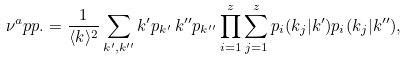Convert formula to latex. <formula><loc_0><loc_0><loc_500><loc_500>\nu ^ { a } p p . = \frac { 1 } { \langle k \rangle ^ { 2 } } \sum _ { k ^ { \prime } , k ^ { \prime \prime } } k ^ { \prime } p _ { k ^ { \prime } } \, k ^ { \prime \prime } p _ { k ^ { \prime \prime } } \prod _ { i = 1 } ^ { z } \sum _ { j = 1 } ^ { z } p _ { i } ( k _ { j } | k ^ { \prime } ) p _ { i } ( k _ { j } | k ^ { \prime \prime } ) ,</formula> 